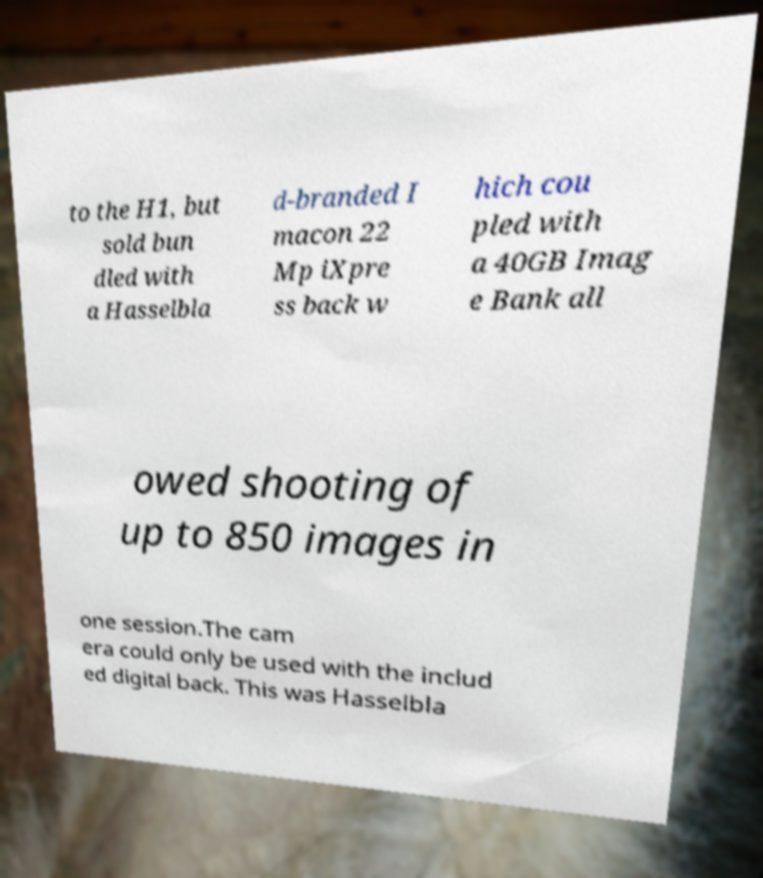Please identify and transcribe the text found in this image. to the H1, but sold bun dled with a Hasselbla d-branded I macon 22 Mp iXpre ss back w hich cou pled with a 40GB Imag e Bank all owed shooting of up to 850 images in one session.The cam era could only be used with the includ ed digital back. This was Hasselbla 